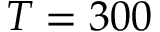Convert formula to latex. <formula><loc_0><loc_0><loc_500><loc_500>T = 3 0 0</formula> 